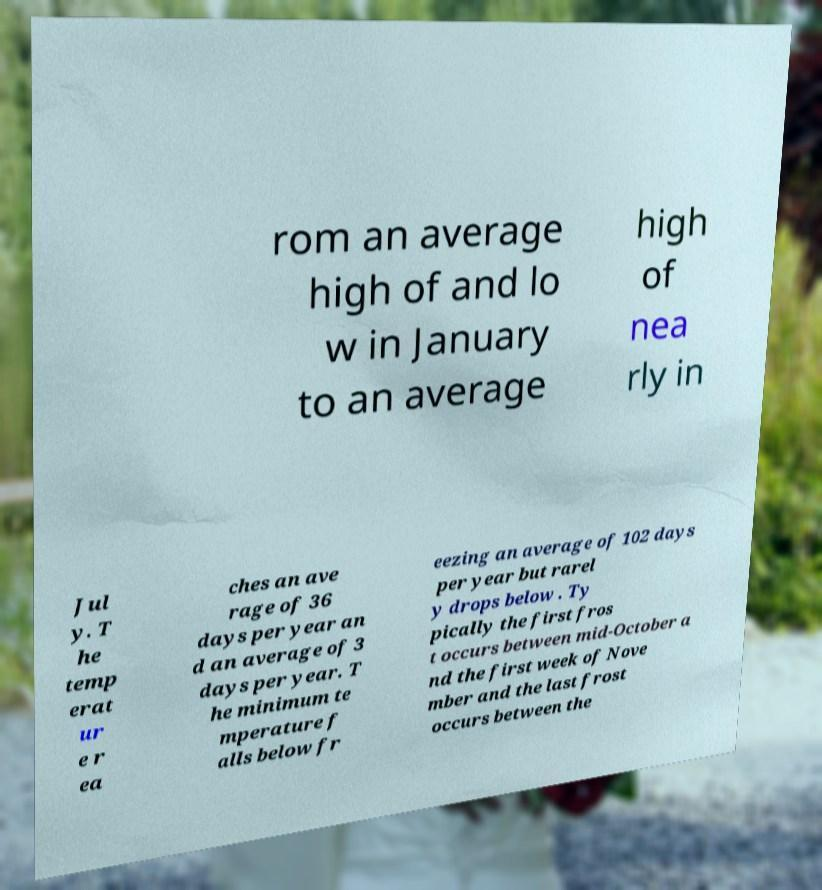Could you extract and type out the text from this image? rom an average high of and lo w in January to an average high of nea rly in Jul y. T he temp erat ur e r ea ches an ave rage of 36 days per year an d an average of 3 days per year. T he minimum te mperature f alls below fr eezing an average of 102 days per year but rarel y drops below . Ty pically the first fros t occurs between mid-October a nd the first week of Nove mber and the last frost occurs between the 